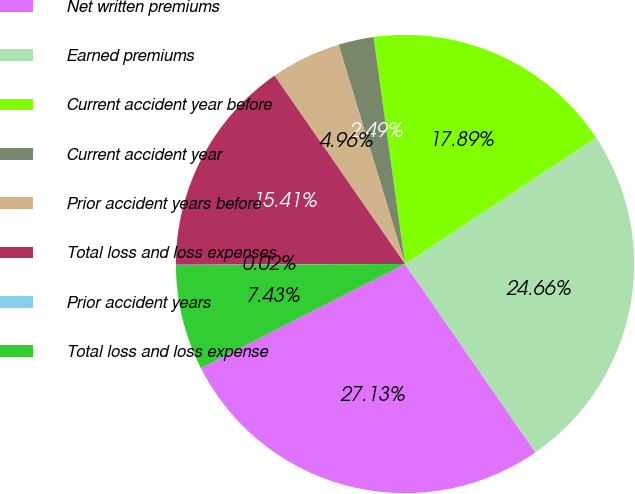Convert chart to OTSL. <chart><loc_0><loc_0><loc_500><loc_500><pie_chart><fcel>Net written premiums<fcel>Earned premiums<fcel>Current accident year before<fcel>Current accident year<fcel>Prior accident years before<fcel>Total loss and loss expenses<fcel>Prior accident years<fcel>Total loss and loss expense<nl><fcel>27.13%<fcel>24.66%<fcel>17.89%<fcel>2.49%<fcel>4.96%<fcel>15.41%<fcel>0.02%<fcel>7.43%<nl></chart> 